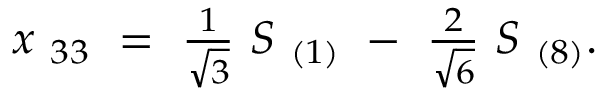<formula> <loc_0><loc_0><loc_500><loc_500>\begin{array} { l } { { x _ { \ 3 3 } \ = \ \frac { 1 } { \sqrt { 3 } } \ S _ { \ ( 1 ) } \ - \ \frac { 2 } { \sqrt { 6 } } \ S _ { \ ( 8 ) } . } } \end{array}</formula> 